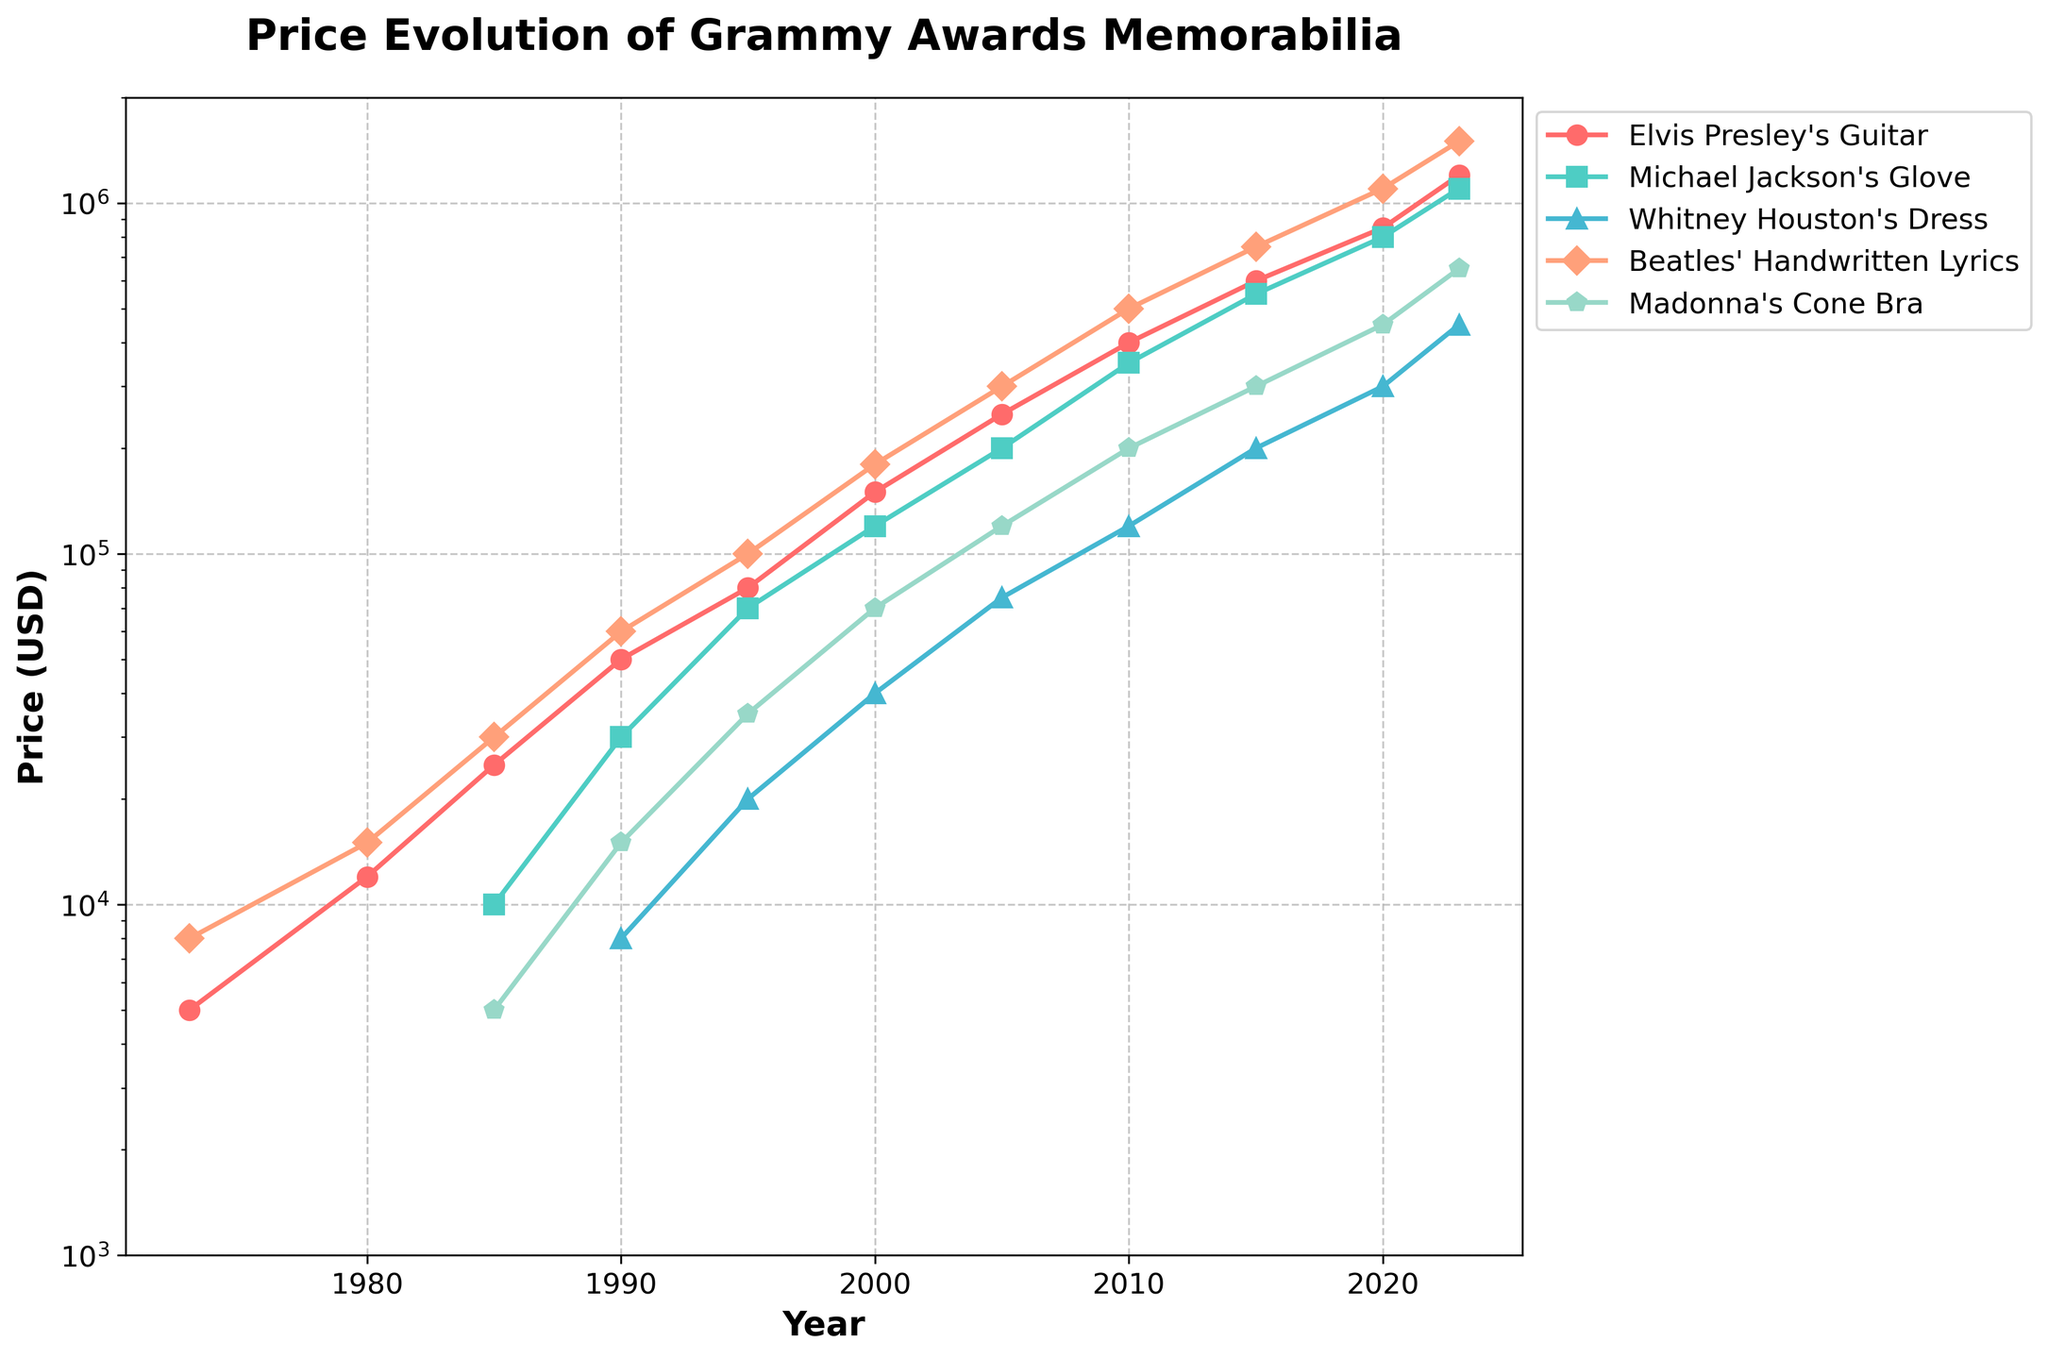Which memorabilia item had the highest price in 2023? Visually scan the chart to 2023 and identify the highest point. The Beatles' Handwritten Lyrics are at the top at $1,500,000.
Answer: Beatles' Handwritten Lyrics What was the price difference between Madonna's Cone Bra and Michael Jackson's Glove in 2020? In 2020, Madonna's Cone Bra was $450,000 and Michael Jackson's Glove was $800,000. Subtract $450,000 from $800,000 to get $350,000.
Answer: $350,000 Which year showed the most significant price increase for Elvis Presley's Guitar? Analyze the year-to-year price increase for Elvis Presley's Guitar. The most considerable jump occurs between 2020 ($850,000) and 2023 ($1,200,000), which is $350,000.
Answer: 2023 By how much did Whitney Houston's Dress increase in price from 1990 to 2023? Check Whitney Houston’s Dress price in 1990 ($8,000) and 2023 ($450,000). Subtract $8,000 from $450,000 to get $442,000.
Answer: $442,000 In which year did all items listed have a price value? Search for the year where none of the items’ lines have gaps. This occurs in 2023.
Answer: 2023 Which item's price reached $200,000 first, and in what year? Compare the items' prices listed and find which was the first to reach $200,000. Elvis Presley's Guitar hit $200,000 in 2005.
Answer: Elvis Presley's Guitar, 2005 Are there any items whose prices remained constant over a period of years? By visually inspecting the chart, none of the price lines remained flat over multiple years, indicating no items had constant prices.
Answer: No What was the total price for all memorabilia items combined in 2010? Sum up the prices in 2010: Elvis Presley's Guitar $400,000, Michael Jackson's Glove $350,000, Whitney Houston's Dress $120,000, Beatles' Handwritten Lyrics $500,000, Madonna's Cone Bra $200,000. Total is $1,570,000.
Answer: $1,570,000 Which was more valuable in 1985, Michael Jackson's Glove or Madonna's Cone Bra? In 1985, Michael Jackson's Glove was $10,000, and Madonna's Cone Bra was $5,000. Michael Jackson's Glove had a higher price.
Answer: Michael Jackson's Glove On average, how much did the price of Beatles' Handwritten Lyrics increase per year from 1973 to 2023? Calculate the price difference over the 50 years: 2023 ($1,500,000) - 1973 ($8,000) = $1,492,000. Divide by the number of years (2023-1973): $1,492,000 / 50.
Answer: $29,840 per year 